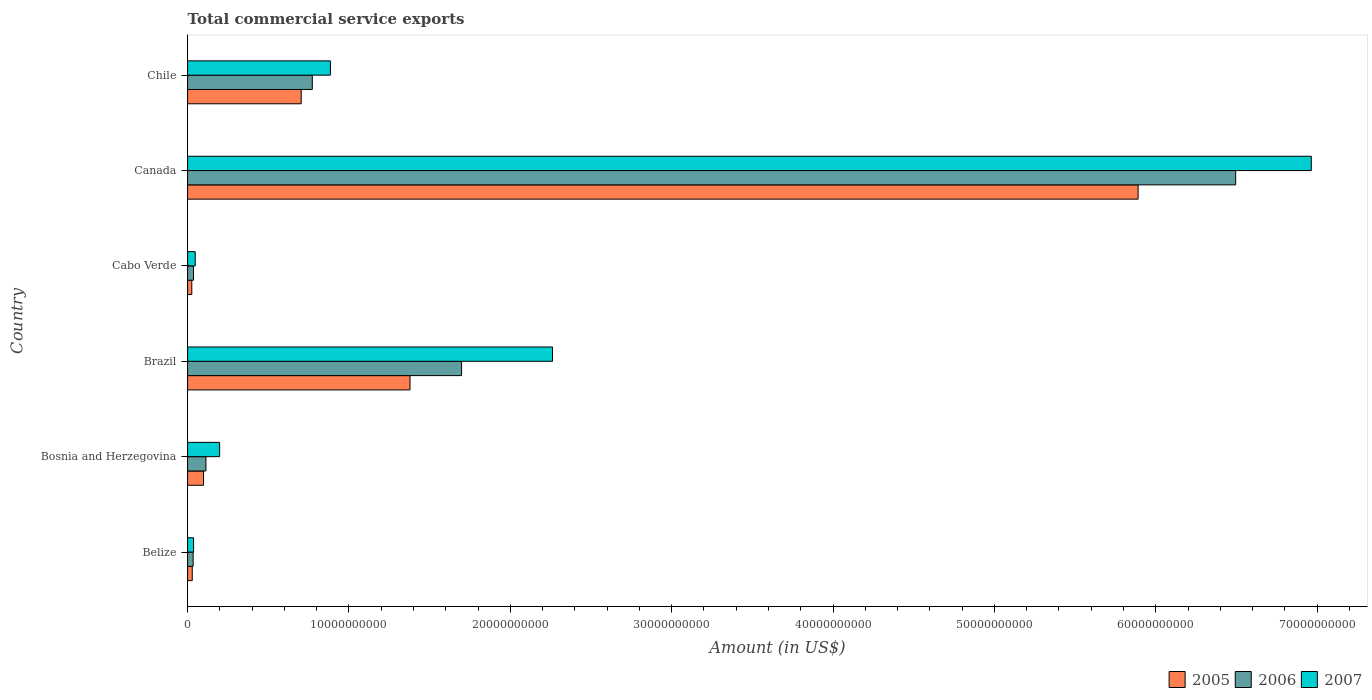How many groups of bars are there?
Offer a very short reply. 6. Are the number of bars per tick equal to the number of legend labels?
Provide a succinct answer. Yes. Are the number of bars on each tick of the Y-axis equal?
Your answer should be very brief. Yes. How many bars are there on the 4th tick from the top?
Make the answer very short. 3. How many bars are there on the 1st tick from the bottom?
Keep it short and to the point. 3. What is the total commercial service exports in 2005 in Chile?
Give a very brief answer. 7.04e+09. Across all countries, what is the maximum total commercial service exports in 2007?
Make the answer very short. 6.96e+1. Across all countries, what is the minimum total commercial service exports in 2006?
Make the answer very short. 3.43e+08. In which country was the total commercial service exports in 2006 maximum?
Your response must be concise. Canada. In which country was the total commercial service exports in 2005 minimum?
Make the answer very short. Cabo Verde. What is the total total commercial service exports in 2007 in the graph?
Give a very brief answer. 1.04e+11. What is the difference between the total commercial service exports in 2006 in Belize and that in Bosnia and Herzegovina?
Keep it short and to the point. -7.94e+08. What is the difference between the total commercial service exports in 2006 in Canada and the total commercial service exports in 2005 in Cabo Verde?
Offer a very short reply. 6.47e+1. What is the average total commercial service exports in 2005 per country?
Keep it short and to the point. 1.35e+1. What is the difference between the total commercial service exports in 2007 and total commercial service exports in 2006 in Cabo Verde?
Offer a very short reply. 1.08e+08. In how many countries, is the total commercial service exports in 2006 greater than 44000000000 US$?
Provide a short and direct response. 1. What is the ratio of the total commercial service exports in 2007 in Belize to that in Bosnia and Herzegovina?
Provide a succinct answer. 0.19. Is the total commercial service exports in 2006 in Belize less than that in Bosnia and Herzegovina?
Your answer should be compact. Yes. Is the difference between the total commercial service exports in 2007 in Brazil and Canada greater than the difference between the total commercial service exports in 2006 in Brazil and Canada?
Offer a terse response. Yes. What is the difference between the highest and the second highest total commercial service exports in 2007?
Your answer should be very brief. 4.70e+1. What is the difference between the highest and the lowest total commercial service exports in 2007?
Offer a very short reply. 6.93e+1. In how many countries, is the total commercial service exports in 2006 greater than the average total commercial service exports in 2006 taken over all countries?
Provide a short and direct response. 2. How many bars are there?
Ensure brevity in your answer.  18. Are all the bars in the graph horizontal?
Your answer should be very brief. Yes. Are the values on the major ticks of X-axis written in scientific E-notation?
Provide a succinct answer. No. Does the graph contain any zero values?
Offer a very short reply. No. How are the legend labels stacked?
Make the answer very short. Horizontal. What is the title of the graph?
Keep it short and to the point. Total commercial service exports. What is the label or title of the Y-axis?
Offer a terse response. Country. What is the Amount (in US$) of 2005 in Belize?
Your answer should be very brief. 2.89e+08. What is the Amount (in US$) in 2006 in Belize?
Your answer should be compact. 3.43e+08. What is the Amount (in US$) of 2007 in Belize?
Your answer should be compact. 3.71e+08. What is the Amount (in US$) of 2005 in Bosnia and Herzegovina?
Provide a succinct answer. 9.87e+08. What is the Amount (in US$) in 2006 in Bosnia and Herzegovina?
Your answer should be compact. 1.14e+09. What is the Amount (in US$) in 2007 in Bosnia and Herzegovina?
Offer a very short reply. 1.99e+09. What is the Amount (in US$) of 2005 in Brazil?
Offer a terse response. 1.38e+1. What is the Amount (in US$) in 2006 in Brazil?
Provide a succinct answer. 1.70e+1. What is the Amount (in US$) in 2007 in Brazil?
Offer a terse response. 2.26e+1. What is the Amount (in US$) in 2005 in Cabo Verde?
Ensure brevity in your answer.  2.60e+08. What is the Amount (in US$) in 2006 in Cabo Verde?
Your response must be concise. 3.66e+08. What is the Amount (in US$) of 2007 in Cabo Verde?
Provide a short and direct response. 4.74e+08. What is the Amount (in US$) in 2005 in Canada?
Provide a succinct answer. 5.89e+1. What is the Amount (in US$) of 2006 in Canada?
Keep it short and to the point. 6.50e+1. What is the Amount (in US$) of 2007 in Canada?
Offer a very short reply. 6.96e+1. What is the Amount (in US$) of 2005 in Chile?
Offer a very short reply. 7.04e+09. What is the Amount (in US$) in 2006 in Chile?
Your answer should be very brief. 7.73e+09. What is the Amount (in US$) in 2007 in Chile?
Offer a terse response. 8.85e+09. Across all countries, what is the maximum Amount (in US$) of 2005?
Make the answer very short. 5.89e+1. Across all countries, what is the maximum Amount (in US$) in 2006?
Ensure brevity in your answer.  6.50e+1. Across all countries, what is the maximum Amount (in US$) in 2007?
Ensure brevity in your answer.  6.96e+1. Across all countries, what is the minimum Amount (in US$) of 2005?
Your response must be concise. 2.60e+08. Across all countries, what is the minimum Amount (in US$) in 2006?
Provide a succinct answer. 3.43e+08. Across all countries, what is the minimum Amount (in US$) in 2007?
Ensure brevity in your answer.  3.71e+08. What is the total Amount (in US$) of 2005 in the graph?
Your answer should be compact. 8.13e+1. What is the total Amount (in US$) in 2006 in the graph?
Ensure brevity in your answer.  9.15e+1. What is the total Amount (in US$) in 2007 in the graph?
Your answer should be compact. 1.04e+11. What is the difference between the Amount (in US$) of 2005 in Belize and that in Bosnia and Herzegovina?
Offer a terse response. -6.97e+08. What is the difference between the Amount (in US$) of 2006 in Belize and that in Bosnia and Herzegovina?
Make the answer very short. -7.94e+08. What is the difference between the Amount (in US$) in 2007 in Belize and that in Bosnia and Herzegovina?
Ensure brevity in your answer.  -1.61e+09. What is the difference between the Amount (in US$) of 2005 in Belize and that in Brazil?
Give a very brief answer. -1.35e+1. What is the difference between the Amount (in US$) in 2006 in Belize and that in Brazil?
Your response must be concise. -1.66e+1. What is the difference between the Amount (in US$) in 2007 in Belize and that in Brazil?
Your answer should be compact. -2.22e+1. What is the difference between the Amount (in US$) of 2005 in Belize and that in Cabo Verde?
Make the answer very short. 2.87e+07. What is the difference between the Amount (in US$) of 2006 in Belize and that in Cabo Verde?
Ensure brevity in your answer.  -2.24e+07. What is the difference between the Amount (in US$) in 2007 in Belize and that in Cabo Verde?
Ensure brevity in your answer.  -1.03e+08. What is the difference between the Amount (in US$) of 2005 in Belize and that in Canada?
Keep it short and to the point. -5.86e+1. What is the difference between the Amount (in US$) of 2006 in Belize and that in Canada?
Your answer should be compact. -6.46e+1. What is the difference between the Amount (in US$) of 2007 in Belize and that in Canada?
Give a very brief answer. -6.93e+1. What is the difference between the Amount (in US$) of 2005 in Belize and that in Chile?
Ensure brevity in your answer.  -6.75e+09. What is the difference between the Amount (in US$) in 2006 in Belize and that in Chile?
Ensure brevity in your answer.  -7.38e+09. What is the difference between the Amount (in US$) of 2007 in Belize and that in Chile?
Offer a very short reply. -8.48e+09. What is the difference between the Amount (in US$) of 2005 in Bosnia and Herzegovina and that in Brazil?
Your response must be concise. -1.28e+1. What is the difference between the Amount (in US$) in 2006 in Bosnia and Herzegovina and that in Brazil?
Your response must be concise. -1.58e+1. What is the difference between the Amount (in US$) of 2007 in Bosnia and Herzegovina and that in Brazil?
Make the answer very short. -2.06e+1. What is the difference between the Amount (in US$) in 2005 in Bosnia and Herzegovina and that in Cabo Verde?
Provide a short and direct response. 7.26e+08. What is the difference between the Amount (in US$) in 2006 in Bosnia and Herzegovina and that in Cabo Verde?
Your answer should be very brief. 7.72e+08. What is the difference between the Amount (in US$) in 2007 in Bosnia and Herzegovina and that in Cabo Verde?
Provide a succinct answer. 1.51e+09. What is the difference between the Amount (in US$) in 2005 in Bosnia and Herzegovina and that in Canada?
Keep it short and to the point. -5.79e+1. What is the difference between the Amount (in US$) of 2006 in Bosnia and Herzegovina and that in Canada?
Your response must be concise. -6.38e+1. What is the difference between the Amount (in US$) of 2007 in Bosnia and Herzegovina and that in Canada?
Offer a terse response. -6.77e+1. What is the difference between the Amount (in US$) in 2005 in Bosnia and Herzegovina and that in Chile?
Make the answer very short. -6.05e+09. What is the difference between the Amount (in US$) in 2006 in Bosnia and Herzegovina and that in Chile?
Give a very brief answer. -6.59e+09. What is the difference between the Amount (in US$) of 2007 in Bosnia and Herzegovina and that in Chile?
Offer a very short reply. -6.87e+09. What is the difference between the Amount (in US$) in 2005 in Brazil and that in Cabo Verde?
Provide a succinct answer. 1.35e+1. What is the difference between the Amount (in US$) of 2006 in Brazil and that in Cabo Verde?
Make the answer very short. 1.66e+1. What is the difference between the Amount (in US$) of 2007 in Brazil and that in Cabo Verde?
Your answer should be very brief. 2.21e+1. What is the difference between the Amount (in US$) in 2005 in Brazil and that in Canada?
Give a very brief answer. -4.51e+1. What is the difference between the Amount (in US$) in 2006 in Brazil and that in Canada?
Ensure brevity in your answer.  -4.80e+1. What is the difference between the Amount (in US$) of 2007 in Brazil and that in Canada?
Your response must be concise. -4.70e+1. What is the difference between the Amount (in US$) in 2005 in Brazil and that in Chile?
Give a very brief answer. 6.74e+09. What is the difference between the Amount (in US$) of 2006 in Brazil and that in Chile?
Provide a succinct answer. 9.25e+09. What is the difference between the Amount (in US$) in 2007 in Brazil and that in Chile?
Your answer should be very brief. 1.38e+1. What is the difference between the Amount (in US$) of 2005 in Cabo Verde and that in Canada?
Offer a very short reply. -5.86e+1. What is the difference between the Amount (in US$) in 2006 in Cabo Verde and that in Canada?
Provide a succinct answer. -6.46e+1. What is the difference between the Amount (in US$) in 2007 in Cabo Verde and that in Canada?
Provide a short and direct response. -6.92e+1. What is the difference between the Amount (in US$) of 2005 in Cabo Verde and that in Chile?
Your answer should be compact. -6.78e+09. What is the difference between the Amount (in US$) of 2006 in Cabo Verde and that in Chile?
Keep it short and to the point. -7.36e+09. What is the difference between the Amount (in US$) in 2007 in Cabo Verde and that in Chile?
Offer a very short reply. -8.38e+09. What is the difference between the Amount (in US$) of 2005 in Canada and that in Chile?
Provide a short and direct response. 5.19e+1. What is the difference between the Amount (in US$) in 2006 in Canada and that in Chile?
Your answer should be very brief. 5.72e+1. What is the difference between the Amount (in US$) in 2007 in Canada and that in Chile?
Offer a terse response. 6.08e+1. What is the difference between the Amount (in US$) in 2005 in Belize and the Amount (in US$) in 2006 in Bosnia and Herzegovina?
Give a very brief answer. -8.48e+08. What is the difference between the Amount (in US$) of 2005 in Belize and the Amount (in US$) of 2007 in Bosnia and Herzegovina?
Ensure brevity in your answer.  -1.70e+09. What is the difference between the Amount (in US$) of 2006 in Belize and the Amount (in US$) of 2007 in Bosnia and Herzegovina?
Your answer should be very brief. -1.64e+09. What is the difference between the Amount (in US$) in 2005 in Belize and the Amount (in US$) in 2006 in Brazil?
Offer a very short reply. -1.67e+1. What is the difference between the Amount (in US$) in 2005 in Belize and the Amount (in US$) in 2007 in Brazil?
Keep it short and to the point. -2.23e+1. What is the difference between the Amount (in US$) of 2006 in Belize and the Amount (in US$) of 2007 in Brazil?
Provide a short and direct response. -2.23e+1. What is the difference between the Amount (in US$) in 2005 in Belize and the Amount (in US$) in 2006 in Cabo Verde?
Your answer should be very brief. -7.64e+07. What is the difference between the Amount (in US$) in 2005 in Belize and the Amount (in US$) in 2007 in Cabo Verde?
Provide a short and direct response. -1.85e+08. What is the difference between the Amount (in US$) in 2006 in Belize and the Amount (in US$) in 2007 in Cabo Verde?
Offer a very short reply. -1.30e+08. What is the difference between the Amount (in US$) of 2005 in Belize and the Amount (in US$) of 2006 in Canada?
Your response must be concise. -6.47e+1. What is the difference between the Amount (in US$) of 2005 in Belize and the Amount (in US$) of 2007 in Canada?
Keep it short and to the point. -6.93e+1. What is the difference between the Amount (in US$) of 2006 in Belize and the Amount (in US$) of 2007 in Canada?
Provide a succinct answer. -6.93e+1. What is the difference between the Amount (in US$) in 2005 in Belize and the Amount (in US$) in 2006 in Chile?
Your response must be concise. -7.44e+09. What is the difference between the Amount (in US$) of 2005 in Belize and the Amount (in US$) of 2007 in Chile?
Make the answer very short. -8.56e+09. What is the difference between the Amount (in US$) in 2006 in Belize and the Amount (in US$) in 2007 in Chile?
Keep it short and to the point. -8.51e+09. What is the difference between the Amount (in US$) of 2005 in Bosnia and Herzegovina and the Amount (in US$) of 2006 in Brazil?
Your answer should be compact. -1.60e+1. What is the difference between the Amount (in US$) of 2005 in Bosnia and Herzegovina and the Amount (in US$) of 2007 in Brazil?
Your answer should be very brief. -2.16e+1. What is the difference between the Amount (in US$) in 2006 in Bosnia and Herzegovina and the Amount (in US$) in 2007 in Brazil?
Offer a terse response. -2.15e+1. What is the difference between the Amount (in US$) of 2005 in Bosnia and Herzegovina and the Amount (in US$) of 2006 in Cabo Verde?
Your answer should be compact. 6.21e+08. What is the difference between the Amount (in US$) in 2005 in Bosnia and Herzegovina and the Amount (in US$) in 2007 in Cabo Verde?
Offer a very short reply. 5.13e+08. What is the difference between the Amount (in US$) of 2006 in Bosnia and Herzegovina and the Amount (in US$) of 2007 in Cabo Verde?
Your answer should be very brief. 6.64e+08. What is the difference between the Amount (in US$) in 2005 in Bosnia and Herzegovina and the Amount (in US$) in 2006 in Canada?
Make the answer very short. -6.40e+1. What is the difference between the Amount (in US$) in 2005 in Bosnia and Herzegovina and the Amount (in US$) in 2007 in Canada?
Offer a terse response. -6.87e+1. What is the difference between the Amount (in US$) in 2006 in Bosnia and Herzegovina and the Amount (in US$) in 2007 in Canada?
Give a very brief answer. -6.85e+1. What is the difference between the Amount (in US$) of 2005 in Bosnia and Herzegovina and the Amount (in US$) of 2006 in Chile?
Offer a terse response. -6.74e+09. What is the difference between the Amount (in US$) in 2005 in Bosnia and Herzegovina and the Amount (in US$) in 2007 in Chile?
Your response must be concise. -7.87e+09. What is the difference between the Amount (in US$) in 2006 in Bosnia and Herzegovina and the Amount (in US$) in 2007 in Chile?
Provide a short and direct response. -7.71e+09. What is the difference between the Amount (in US$) of 2005 in Brazil and the Amount (in US$) of 2006 in Cabo Verde?
Provide a short and direct response. 1.34e+1. What is the difference between the Amount (in US$) in 2005 in Brazil and the Amount (in US$) in 2007 in Cabo Verde?
Provide a succinct answer. 1.33e+1. What is the difference between the Amount (in US$) of 2006 in Brazil and the Amount (in US$) of 2007 in Cabo Verde?
Provide a succinct answer. 1.65e+1. What is the difference between the Amount (in US$) of 2005 in Brazil and the Amount (in US$) of 2006 in Canada?
Your answer should be compact. -5.12e+1. What is the difference between the Amount (in US$) of 2005 in Brazil and the Amount (in US$) of 2007 in Canada?
Offer a terse response. -5.59e+1. What is the difference between the Amount (in US$) in 2006 in Brazil and the Amount (in US$) in 2007 in Canada?
Your answer should be very brief. -5.27e+1. What is the difference between the Amount (in US$) of 2005 in Brazil and the Amount (in US$) of 2006 in Chile?
Make the answer very short. 6.06e+09. What is the difference between the Amount (in US$) in 2005 in Brazil and the Amount (in US$) in 2007 in Chile?
Your response must be concise. 4.93e+09. What is the difference between the Amount (in US$) of 2006 in Brazil and the Amount (in US$) of 2007 in Chile?
Keep it short and to the point. 8.13e+09. What is the difference between the Amount (in US$) in 2005 in Cabo Verde and the Amount (in US$) in 2006 in Canada?
Offer a very short reply. -6.47e+1. What is the difference between the Amount (in US$) of 2005 in Cabo Verde and the Amount (in US$) of 2007 in Canada?
Offer a very short reply. -6.94e+1. What is the difference between the Amount (in US$) in 2006 in Cabo Verde and the Amount (in US$) in 2007 in Canada?
Ensure brevity in your answer.  -6.93e+1. What is the difference between the Amount (in US$) in 2005 in Cabo Verde and the Amount (in US$) in 2006 in Chile?
Ensure brevity in your answer.  -7.47e+09. What is the difference between the Amount (in US$) in 2005 in Cabo Verde and the Amount (in US$) in 2007 in Chile?
Make the answer very short. -8.59e+09. What is the difference between the Amount (in US$) in 2006 in Cabo Verde and the Amount (in US$) in 2007 in Chile?
Your answer should be compact. -8.49e+09. What is the difference between the Amount (in US$) in 2005 in Canada and the Amount (in US$) in 2006 in Chile?
Make the answer very short. 5.12e+1. What is the difference between the Amount (in US$) of 2005 in Canada and the Amount (in US$) of 2007 in Chile?
Your response must be concise. 5.01e+1. What is the difference between the Amount (in US$) of 2006 in Canada and the Amount (in US$) of 2007 in Chile?
Make the answer very short. 5.61e+1. What is the average Amount (in US$) of 2005 per country?
Make the answer very short. 1.35e+1. What is the average Amount (in US$) of 2006 per country?
Your response must be concise. 1.53e+1. What is the average Amount (in US$) of 2007 per country?
Offer a very short reply. 1.73e+1. What is the difference between the Amount (in US$) of 2005 and Amount (in US$) of 2006 in Belize?
Your answer should be compact. -5.40e+07. What is the difference between the Amount (in US$) in 2005 and Amount (in US$) in 2007 in Belize?
Offer a terse response. -8.18e+07. What is the difference between the Amount (in US$) in 2006 and Amount (in US$) in 2007 in Belize?
Provide a succinct answer. -2.77e+07. What is the difference between the Amount (in US$) in 2005 and Amount (in US$) in 2006 in Bosnia and Herzegovina?
Give a very brief answer. -1.51e+08. What is the difference between the Amount (in US$) of 2005 and Amount (in US$) of 2007 in Bosnia and Herzegovina?
Keep it short and to the point. -9.98e+08. What is the difference between the Amount (in US$) of 2006 and Amount (in US$) of 2007 in Bosnia and Herzegovina?
Give a very brief answer. -8.48e+08. What is the difference between the Amount (in US$) in 2005 and Amount (in US$) in 2006 in Brazil?
Your answer should be compact. -3.19e+09. What is the difference between the Amount (in US$) of 2005 and Amount (in US$) of 2007 in Brazil?
Your response must be concise. -8.83e+09. What is the difference between the Amount (in US$) in 2006 and Amount (in US$) in 2007 in Brazil?
Ensure brevity in your answer.  -5.64e+09. What is the difference between the Amount (in US$) of 2005 and Amount (in US$) of 2006 in Cabo Verde?
Provide a short and direct response. -1.05e+08. What is the difference between the Amount (in US$) of 2005 and Amount (in US$) of 2007 in Cabo Verde?
Make the answer very short. -2.13e+08. What is the difference between the Amount (in US$) of 2006 and Amount (in US$) of 2007 in Cabo Verde?
Offer a very short reply. -1.08e+08. What is the difference between the Amount (in US$) of 2005 and Amount (in US$) of 2006 in Canada?
Make the answer very short. -6.05e+09. What is the difference between the Amount (in US$) in 2005 and Amount (in US$) in 2007 in Canada?
Your answer should be compact. -1.07e+1. What is the difference between the Amount (in US$) of 2006 and Amount (in US$) of 2007 in Canada?
Your answer should be compact. -4.69e+09. What is the difference between the Amount (in US$) of 2005 and Amount (in US$) of 2006 in Chile?
Keep it short and to the point. -6.87e+08. What is the difference between the Amount (in US$) of 2005 and Amount (in US$) of 2007 in Chile?
Offer a terse response. -1.81e+09. What is the difference between the Amount (in US$) of 2006 and Amount (in US$) of 2007 in Chile?
Offer a very short reply. -1.12e+09. What is the ratio of the Amount (in US$) of 2005 in Belize to that in Bosnia and Herzegovina?
Offer a terse response. 0.29. What is the ratio of the Amount (in US$) of 2006 in Belize to that in Bosnia and Herzegovina?
Your response must be concise. 0.3. What is the ratio of the Amount (in US$) of 2007 in Belize to that in Bosnia and Herzegovina?
Offer a terse response. 0.19. What is the ratio of the Amount (in US$) in 2005 in Belize to that in Brazil?
Your answer should be very brief. 0.02. What is the ratio of the Amount (in US$) of 2006 in Belize to that in Brazil?
Your answer should be very brief. 0.02. What is the ratio of the Amount (in US$) of 2007 in Belize to that in Brazil?
Provide a short and direct response. 0.02. What is the ratio of the Amount (in US$) of 2005 in Belize to that in Cabo Verde?
Provide a short and direct response. 1.11. What is the ratio of the Amount (in US$) in 2006 in Belize to that in Cabo Verde?
Give a very brief answer. 0.94. What is the ratio of the Amount (in US$) in 2007 in Belize to that in Cabo Verde?
Make the answer very short. 0.78. What is the ratio of the Amount (in US$) of 2005 in Belize to that in Canada?
Offer a terse response. 0. What is the ratio of the Amount (in US$) of 2006 in Belize to that in Canada?
Your answer should be very brief. 0.01. What is the ratio of the Amount (in US$) of 2007 in Belize to that in Canada?
Give a very brief answer. 0.01. What is the ratio of the Amount (in US$) in 2005 in Belize to that in Chile?
Your response must be concise. 0.04. What is the ratio of the Amount (in US$) of 2006 in Belize to that in Chile?
Provide a succinct answer. 0.04. What is the ratio of the Amount (in US$) of 2007 in Belize to that in Chile?
Make the answer very short. 0.04. What is the ratio of the Amount (in US$) in 2005 in Bosnia and Herzegovina to that in Brazil?
Your answer should be very brief. 0.07. What is the ratio of the Amount (in US$) of 2006 in Bosnia and Herzegovina to that in Brazil?
Ensure brevity in your answer.  0.07. What is the ratio of the Amount (in US$) in 2007 in Bosnia and Herzegovina to that in Brazil?
Offer a very short reply. 0.09. What is the ratio of the Amount (in US$) of 2005 in Bosnia and Herzegovina to that in Cabo Verde?
Provide a succinct answer. 3.79. What is the ratio of the Amount (in US$) of 2006 in Bosnia and Herzegovina to that in Cabo Verde?
Provide a succinct answer. 3.11. What is the ratio of the Amount (in US$) in 2007 in Bosnia and Herzegovina to that in Cabo Verde?
Your response must be concise. 4.19. What is the ratio of the Amount (in US$) of 2005 in Bosnia and Herzegovina to that in Canada?
Offer a very short reply. 0.02. What is the ratio of the Amount (in US$) in 2006 in Bosnia and Herzegovina to that in Canada?
Your answer should be compact. 0.02. What is the ratio of the Amount (in US$) of 2007 in Bosnia and Herzegovina to that in Canada?
Your response must be concise. 0.03. What is the ratio of the Amount (in US$) in 2005 in Bosnia and Herzegovina to that in Chile?
Provide a succinct answer. 0.14. What is the ratio of the Amount (in US$) of 2006 in Bosnia and Herzegovina to that in Chile?
Ensure brevity in your answer.  0.15. What is the ratio of the Amount (in US$) in 2007 in Bosnia and Herzegovina to that in Chile?
Make the answer very short. 0.22. What is the ratio of the Amount (in US$) in 2005 in Brazil to that in Cabo Verde?
Your answer should be very brief. 52.92. What is the ratio of the Amount (in US$) in 2006 in Brazil to that in Cabo Verde?
Your answer should be very brief. 46.44. What is the ratio of the Amount (in US$) of 2007 in Brazil to that in Cabo Verde?
Your answer should be very brief. 47.74. What is the ratio of the Amount (in US$) in 2005 in Brazil to that in Canada?
Your response must be concise. 0.23. What is the ratio of the Amount (in US$) in 2006 in Brazil to that in Canada?
Offer a terse response. 0.26. What is the ratio of the Amount (in US$) in 2007 in Brazil to that in Canada?
Your answer should be very brief. 0.32. What is the ratio of the Amount (in US$) of 2005 in Brazil to that in Chile?
Your answer should be very brief. 1.96. What is the ratio of the Amount (in US$) in 2006 in Brazil to that in Chile?
Offer a very short reply. 2.2. What is the ratio of the Amount (in US$) of 2007 in Brazil to that in Chile?
Your answer should be compact. 2.55. What is the ratio of the Amount (in US$) of 2005 in Cabo Verde to that in Canada?
Keep it short and to the point. 0. What is the ratio of the Amount (in US$) of 2006 in Cabo Verde to that in Canada?
Keep it short and to the point. 0.01. What is the ratio of the Amount (in US$) in 2007 in Cabo Verde to that in Canada?
Your response must be concise. 0.01. What is the ratio of the Amount (in US$) of 2005 in Cabo Verde to that in Chile?
Make the answer very short. 0.04. What is the ratio of the Amount (in US$) in 2006 in Cabo Verde to that in Chile?
Ensure brevity in your answer.  0.05. What is the ratio of the Amount (in US$) in 2007 in Cabo Verde to that in Chile?
Your answer should be very brief. 0.05. What is the ratio of the Amount (in US$) in 2005 in Canada to that in Chile?
Keep it short and to the point. 8.37. What is the ratio of the Amount (in US$) of 2006 in Canada to that in Chile?
Make the answer very short. 8.4. What is the ratio of the Amount (in US$) of 2007 in Canada to that in Chile?
Keep it short and to the point. 7.87. What is the difference between the highest and the second highest Amount (in US$) in 2005?
Your answer should be compact. 4.51e+1. What is the difference between the highest and the second highest Amount (in US$) in 2006?
Your answer should be very brief. 4.80e+1. What is the difference between the highest and the second highest Amount (in US$) of 2007?
Ensure brevity in your answer.  4.70e+1. What is the difference between the highest and the lowest Amount (in US$) of 2005?
Offer a very short reply. 5.86e+1. What is the difference between the highest and the lowest Amount (in US$) of 2006?
Your response must be concise. 6.46e+1. What is the difference between the highest and the lowest Amount (in US$) of 2007?
Provide a succinct answer. 6.93e+1. 